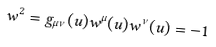<formula> <loc_0><loc_0><loc_500><loc_500>w ^ { 2 } = g _ { \mu \nu } ( u ) w ^ { \mu } ( u ) w ^ { \nu } ( u ) = - 1</formula> 